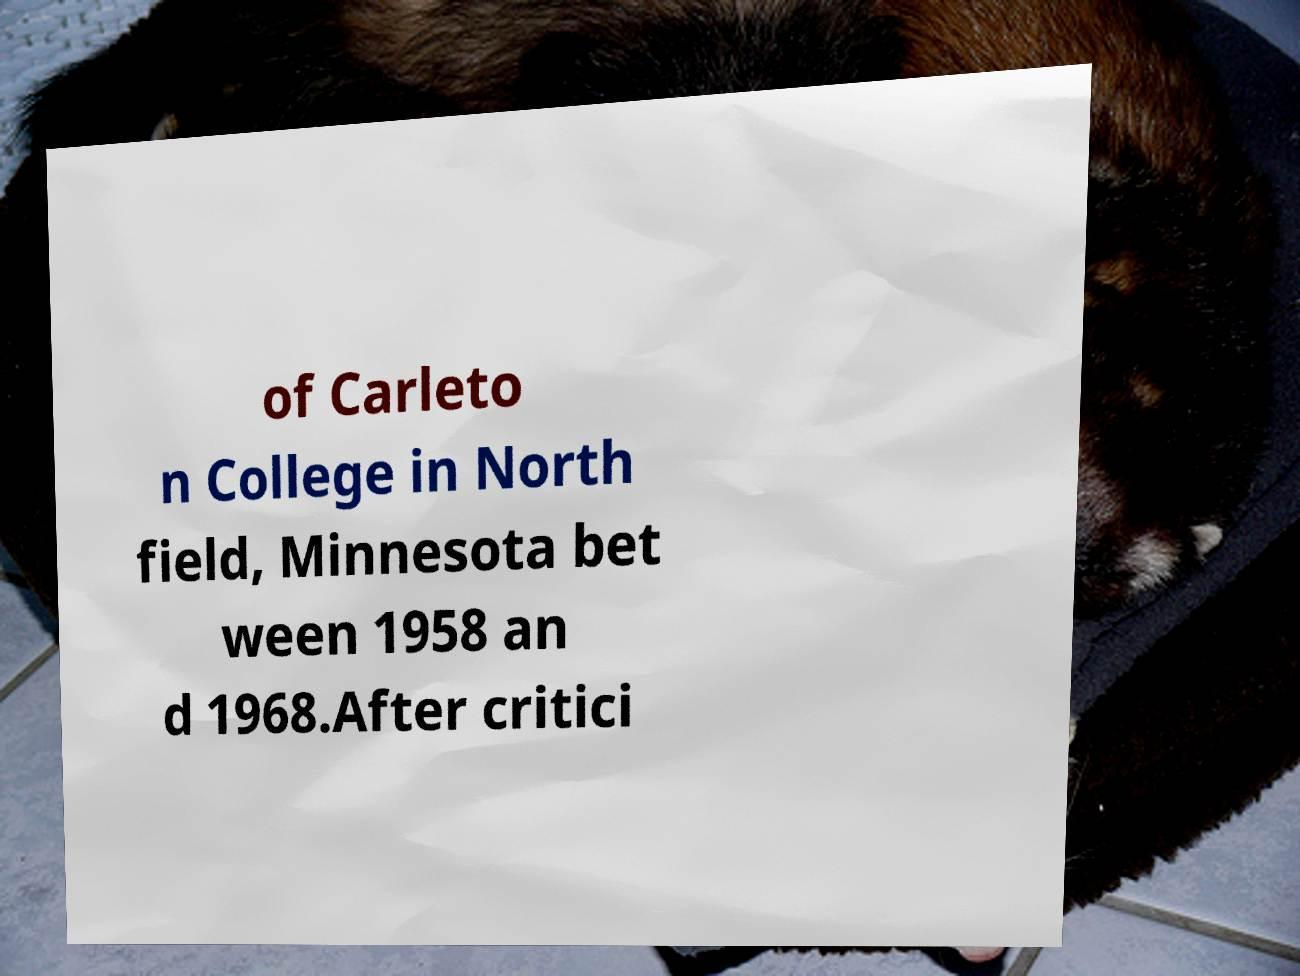Could you assist in decoding the text presented in this image and type it out clearly? of Carleto n College in North field, Minnesota bet ween 1958 an d 1968.After critici 